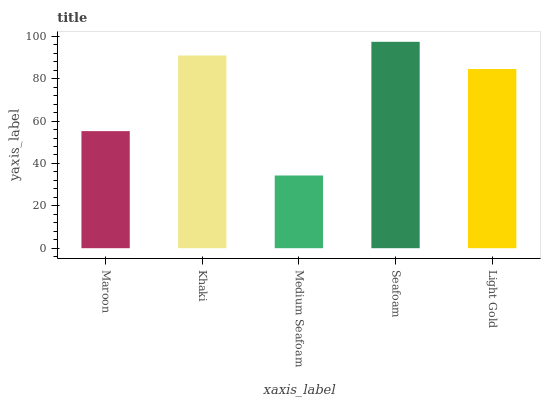Is Medium Seafoam the minimum?
Answer yes or no. Yes. Is Seafoam the maximum?
Answer yes or no. Yes. Is Khaki the minimum?
Answer yes or no. No. Is Khaki the maximum?
Answer yes or no. No. Is Khaki greater than Maroon?
Answer yes or no. Yes. Is Maroon less than Khaki?
Answer yes or no. Yes. Is Maroon greater than Khaki?
Answer yes or no. No. Is Khaki less than Maroon?
Answer yes or no. No. Is Light Gold the high median?
Answer yes or no. Yes. Is Light Gold the low median?
Answer yes or no. Yes. Is Seafoam the high median?
Answer yes or no. No. Is Seafoam the low median?
Answer yes or no. No. 